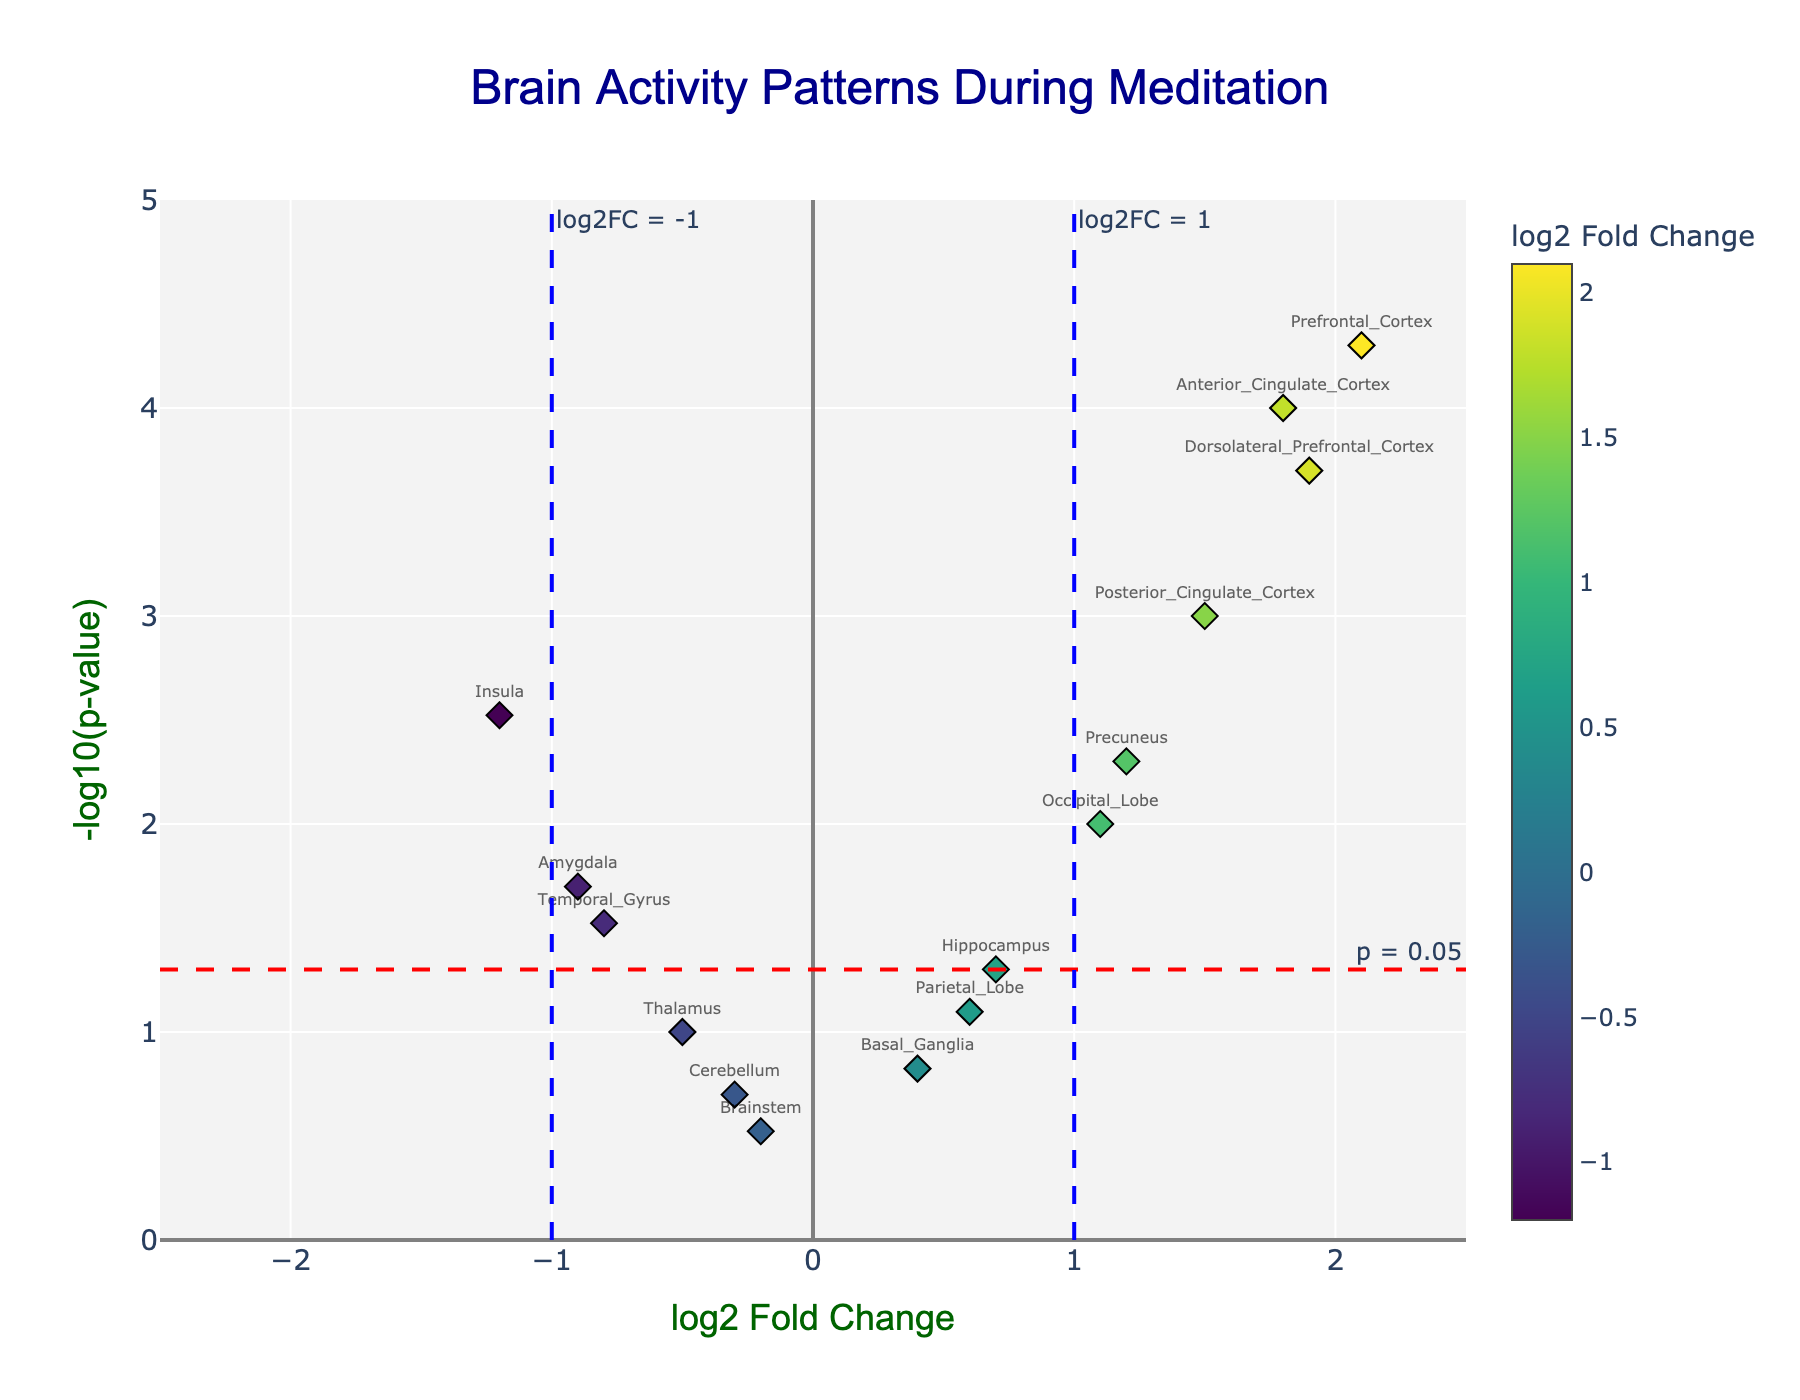Which region shows the highest log2 Fold Change? The highest log2 Fold Change can be identified by finding the point that is farthest to the right on the x-axis. According to the data and the plot, the Prefrontal Cortex has the highest log2 Fold Change of 2.1.
Answer: Prefrontal Cortex What is the title of the plot? The title of the plot is usually placed at the top center of the figure. In this case, it reads "Brain Activity Patterns During Meditation."
Answer: Brain Activity Patterns During Meditation How many brain regions have a p-value less than 0.05? To determine this, look for points above the horizontal red dashed line indicating a p-value of 0.05. By counting these points, we find that the regions are Insula, Anterior Cingulate Cortex, Amygdala, Prefrontal Cortex, Posterior Cingulate Cortex, Precuneus, Dorsolateral Prefrontal Cortex, Temporal Gyrus, and Occipital Lobe, making a total of 9.
Answer: 9 Which brain region has the lowest p-value? The lowest p-value can be identified by the highest point on the y-axis since -log10(p-value) is plotted on the y-axis. The Anterior Cingulate Cortex is at the highest point on the y-axis, indicating it has the lowest p-value of 0.0001.
Answer: Anterior Cingulate Cortex Are any brain regions located below the threshold line for log2 Fold Change of -1? Examine the plot for any points located to the left of the vertical blue dashed line at -1 on the x-axis. The Insula is the only region below this threshold.
Answer: Yes What is the log2 Fold Change and p-value of the Anterior Cingulate Cortex? Hovering over the Anterior Cingulate Cortex point, the log2 Fold Change is labeled as 1.8, and the p-value is 0.0001. These values can also be confirmed from the dataset.
Answer: log2 Fold Change: 1.8, p-value: 0.0001 Which brain regions are activated (log2 Fold Change > 0) and have a p-value less than 0.05? Look for points to the right of the vertical center line (log2 Fold Change > 0) and above the horizontal red dashed line (-log10(p-value) > -log10(0.05)). These regions are Anterior Cingulate Cortex, Prefrontal Cortex, Posterior Cingulate Cortex, Precuneus, Dorsolateral Prefrontal Cortex, and Occipital Lobe.
Answer: Anterior Cingulate Cortex, Prefrontal Cortex, Posterior Cingulate Cortex, Precuneus, Dorsolateral Prefrontal Cortex, Occipital Lobe What is the y-axis label of the plot? The y-axis label is typically displayed beside the corresponding axis. In this plot, it reads '-log10(p-value).'
Answer: -log10(p-value) Which brain region has a log2 Fold Change closest to zero and what is its p-value? Determine which point is closest to the central vertical line at log2 Fold Change = 0. The Brainstem has a log2 Fold Change of -0.2, which is closest to zero. Its p-value is 0.3.
Answer: Brainstem, p-value: 0.3 